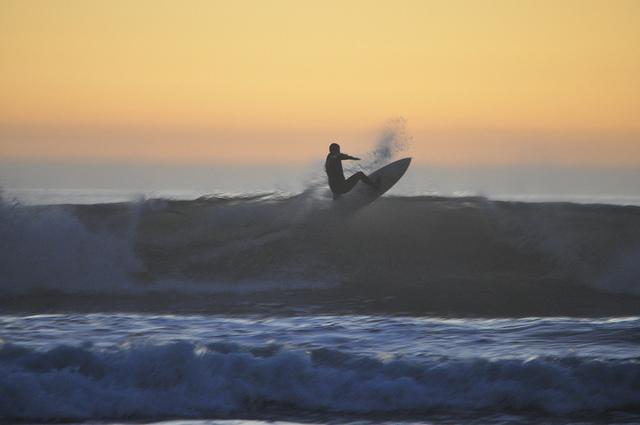What is the man doing?
Concise answer only. Surfing. What is he doing on the wave?
Keep it brief. Surfing. What color is the photo?
Keep it brief. Blue. Is this photo taken in black n white?
Keep it brief. No. What is he riding on?
Be succinct. Surfboard. Is this man in freshwater?
Answer briefly. No. 